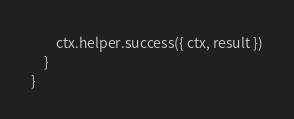<code> <loc_0><loc_0><loc_500><loc_500><_TypeScript_>
        ctx.helper.success({ ctx, result })
    }
}
</code> 